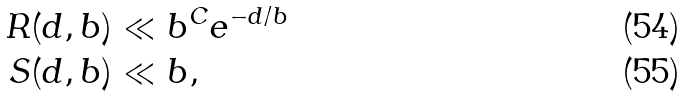<formula> <loc_0><loc_0><loc_500><loc_500>R ( d , b ) & \ll b ^ { C } e ^ { - d / b } \\ S ( d , b ) & \ll b ,</formula> 